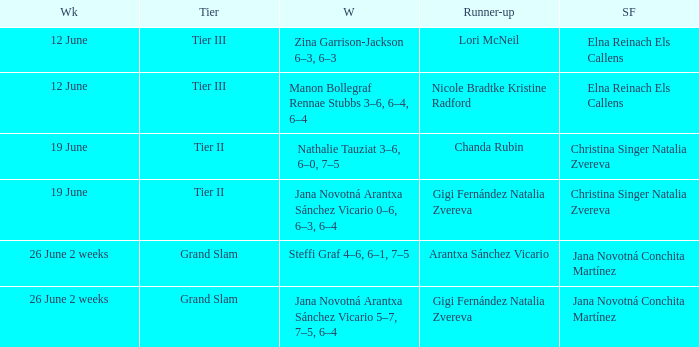Who is the winner in the week listed as 26 June 2 weeks, when the runner-up is Arantxa Sánchez Vicario? Steffi Graf 4–6, 6–1, 7–5. 